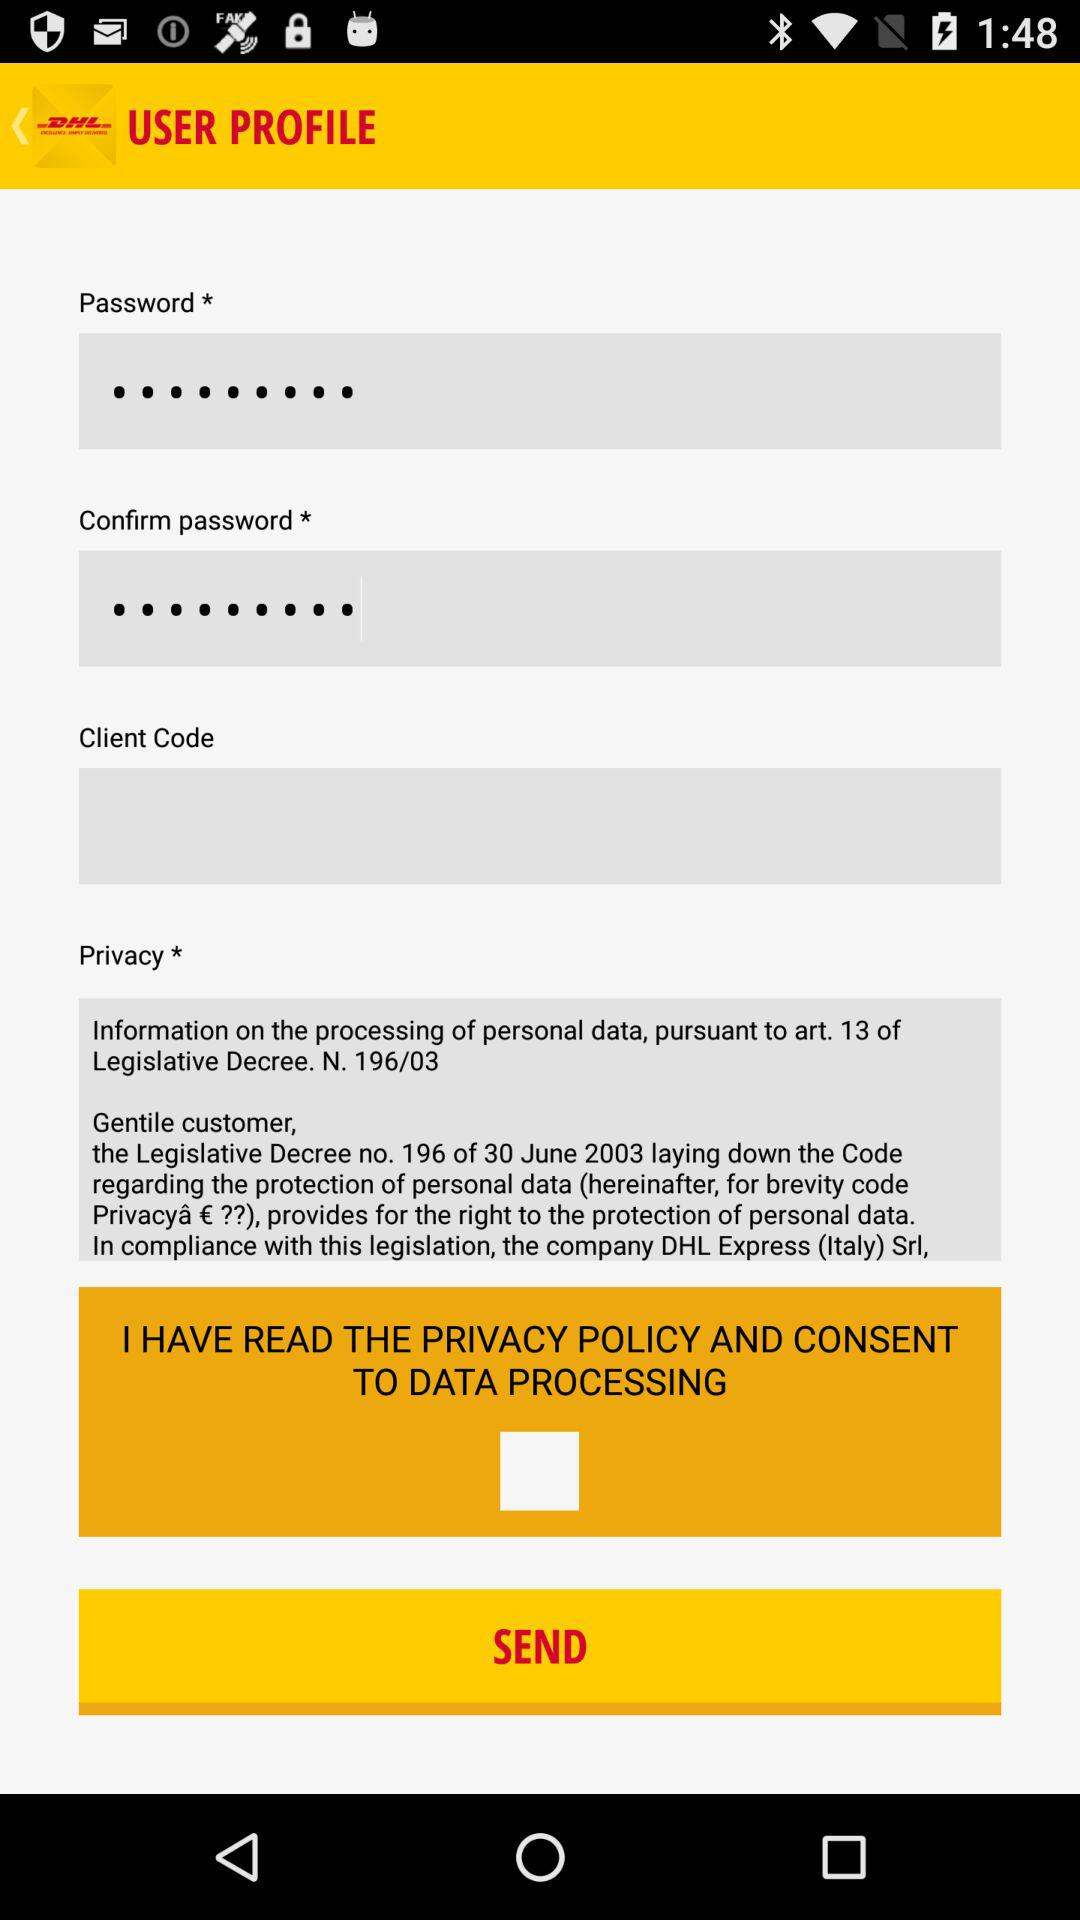What's the status of "I HAVE READ THE PRIVACY POLICY AND CONSENT TO DATA PROCESSING"? The status is "off". 